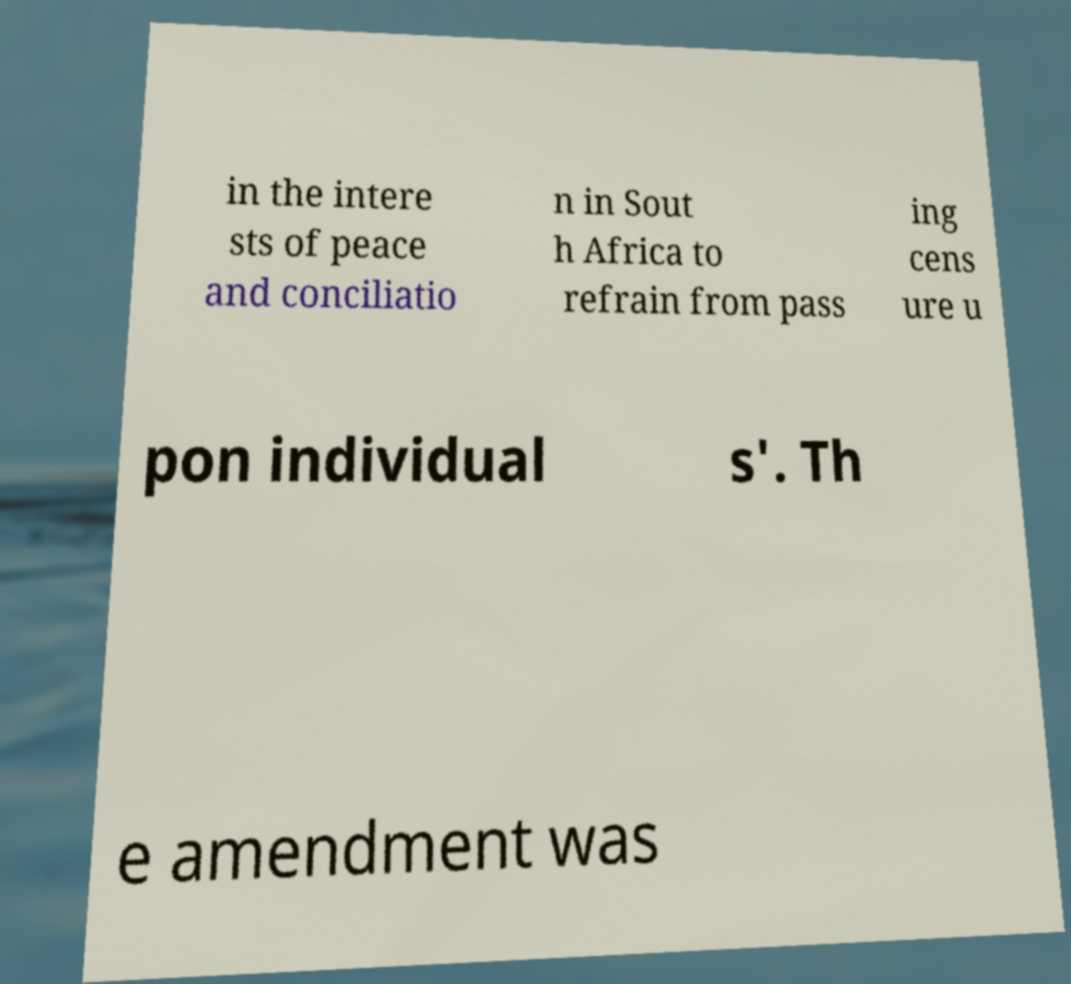Please read and relay the text visible in this image. What does it say? in the intere sts of peace and conciliatio n in Sout h Africa to refrain from pass ing cens ure u pon individual s'. Th e amendment was 